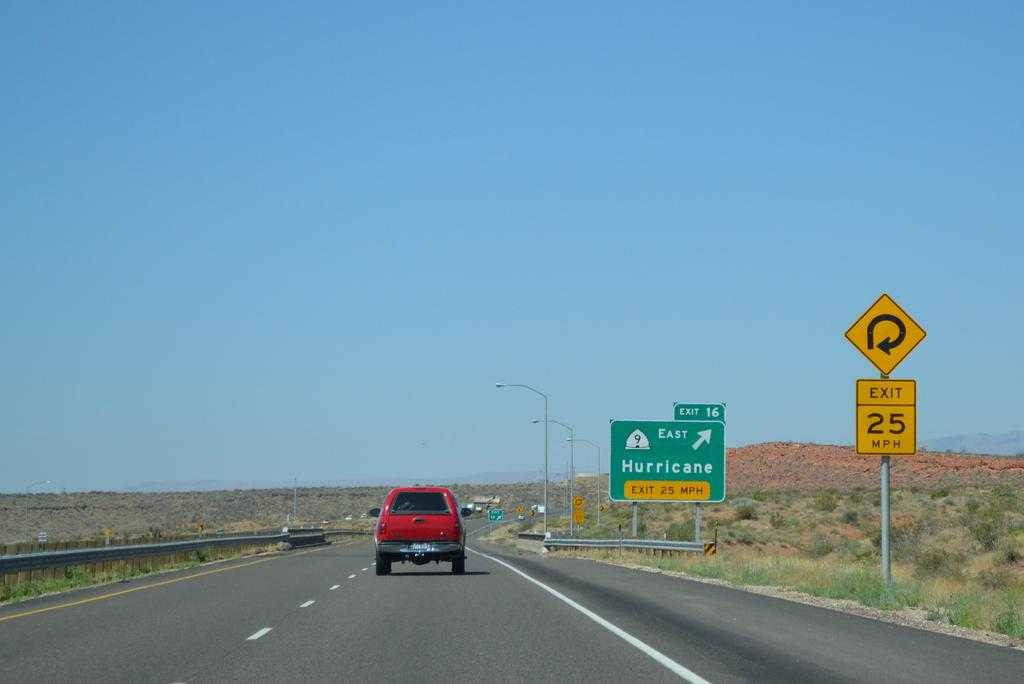<image>
Summarize the visual content of the image. Interstate 15 in Utah featuring exit 14 on to State route 9 which leads to Hurricane 